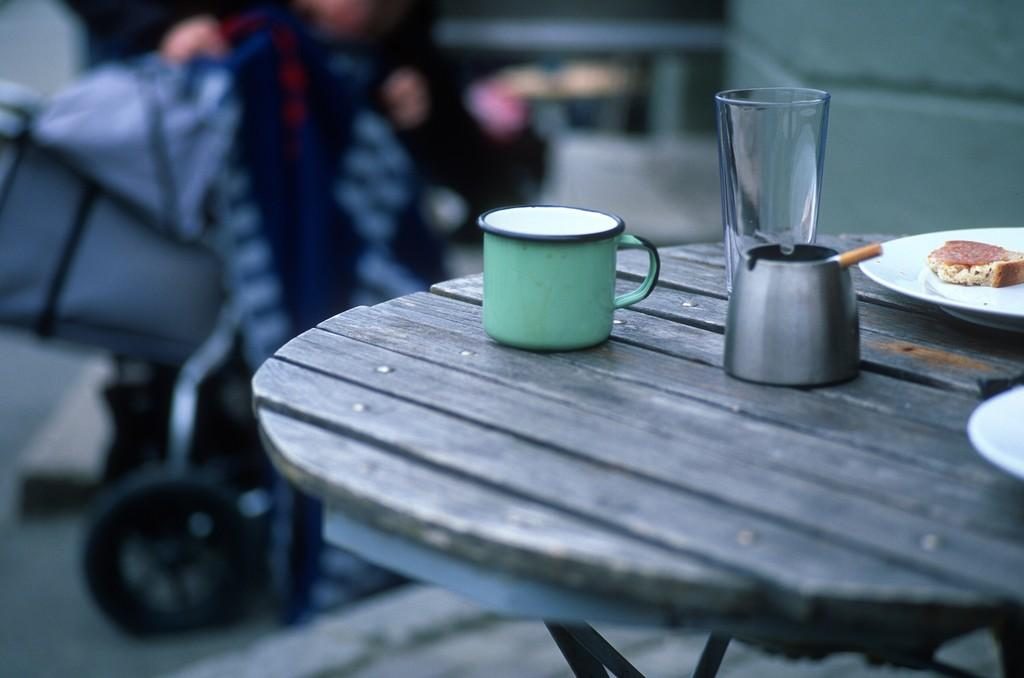What piece of furniture is present in the image? There is a table in the image. What items can be seen on the table? There is a cup, a glass, and plates on the table. Is there any food visible in the image? Yes, there is food on one of the plates. How would you describe the background of the image? The background of the image is blurred. What type of minister is standing next to the table in the image? There is no minister present in the image; it only features a table with various items on it. 